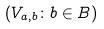<formula> <loc_0><loc_0><loc_500><loc_500>( V _ { a , b } \colon b \in B )</formula> 